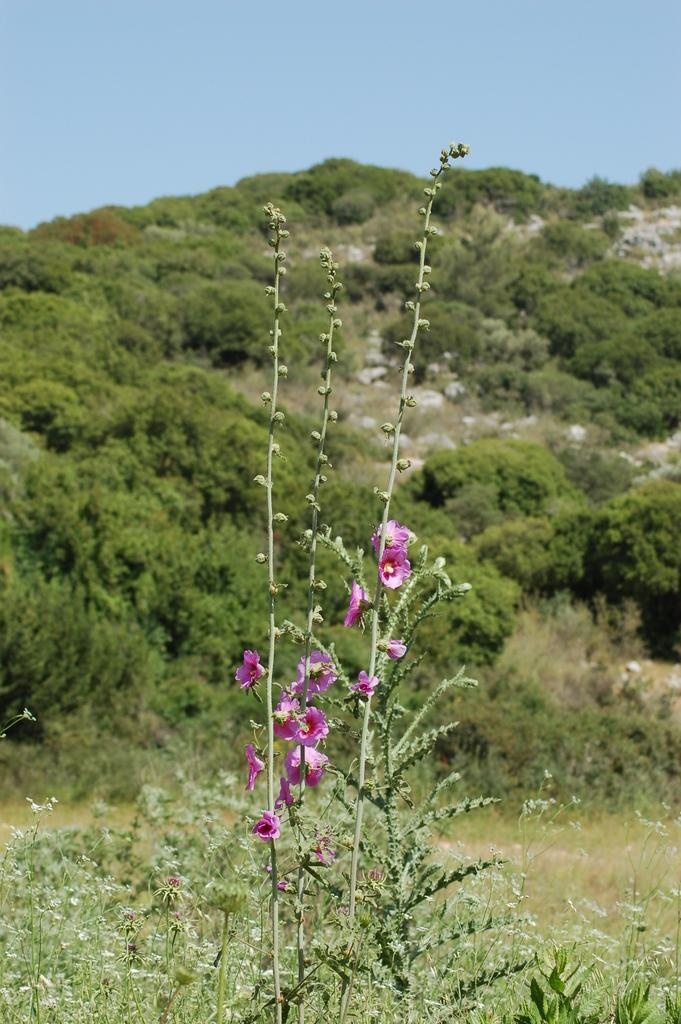What type of plants are at the bottom of the image? There are plants with flowers at the bottom of the image. What can be seen in the background of the image? There are trees and rocks in the background of the image. What is visible at the top of the image? The sky is visible at the top of the image. What grade does the disease receive in the image? There is no mention of a disease or any grading system in the image. Can you tell me how many people are swimming in the image? There is no water or swimming activity depicted in the image. 